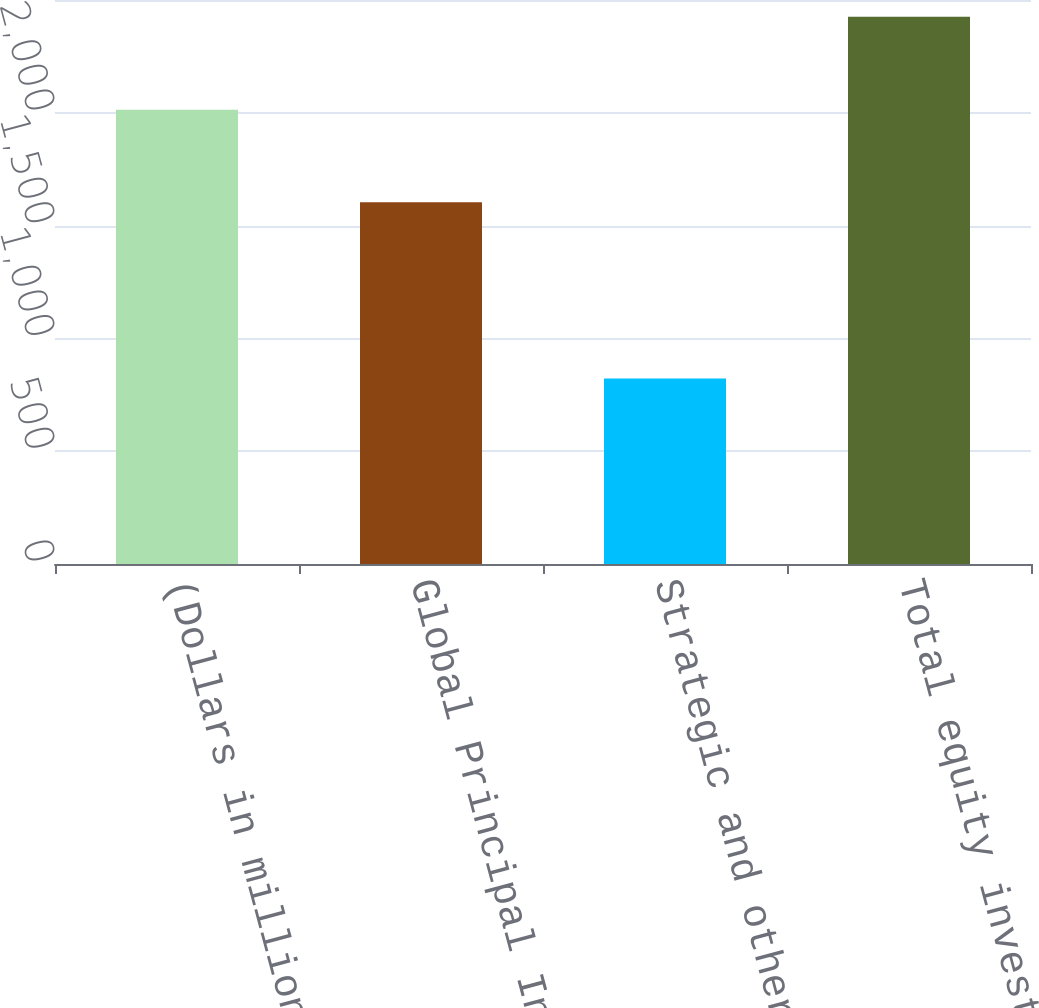Convert chart to OTSL. <chart><loc_0><loc_0><loc_500><loc_500><bar_chart><fcel>(Dollars in millions)<fcel>Global Principal Investments<fcel>Strategic and other<fcel>Total equity investments<nl><fcel>2013<fcel>1604<fcel>822<fcel>2426<nl></chart> 